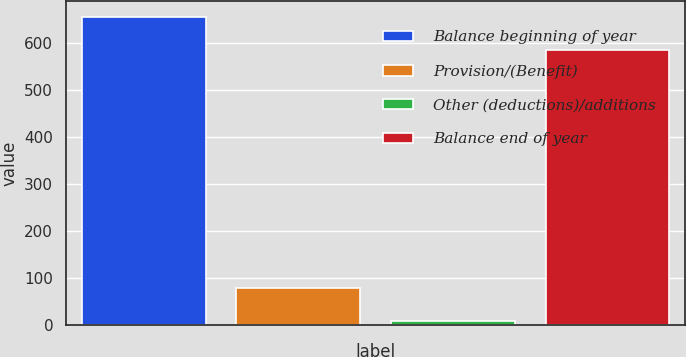Convert chart to OTSL. <chart><loc_0><loc_0><loc_500><loc_500><bar_chart><fcel>Balance beginning of year<fcel>Provision/(Benefit)<fcel>Other (deductions)/additions<fcel>Balance end of year<nl><fcel>657<fcel>78<fcel>7<fcel>586<nl></chart> 